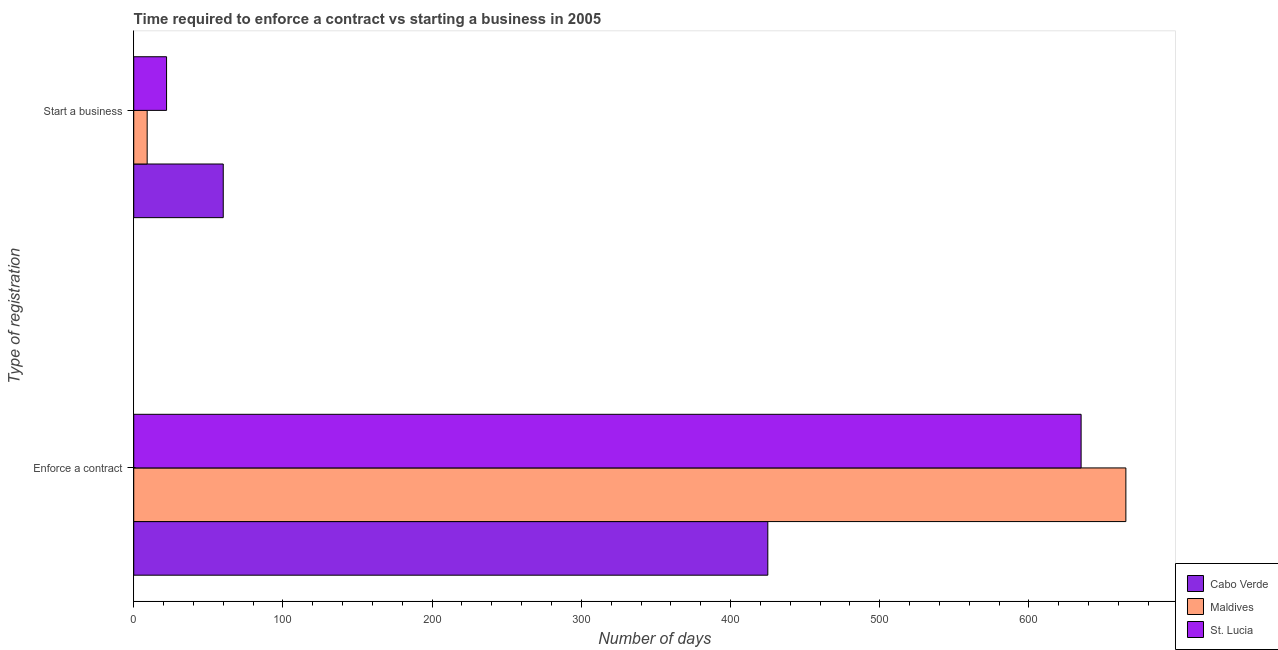Are the number of bars per tick equal to the number of legend labels?
Give a very brief answer. Yes. How many bars are there on the 2nd tick from the top?
Your answer should be very brief. 3. How many bars are there on the 2nd tick from the bottom?
Provide a succinct answer. 3. What is the label of the 2nd group of bars from the top?
Offer a very short reply. Enforce a contract. What is the number of days to enforece a contract in Maldives?
Provide a short and direct response. 665. Across all countries, what is the maximum number of days to enforece a contract?
Provide a succinct answer. 665. Across all countries, what is the minimum number of days to start a business?
Offer a terse response. 9. In which country was the number of days to start a business maximum?
Offer a terse response. Cabo Verde. In which country was the number of days to start a business minimum?
Your answer should be very brief. Maldives. What is the total number of days to enforece a contract in the graph?
Offer a very short reply. 1725. What is the difference between the number of days to start a business in Maldives and that in St. Lucia?
Keep it short and to the point. -13. What is the difference between the number of days to start a business in Maldives and the number of days to enforece a contract in Cabo Verde?
Keep it short and to the point. -416. What is the average number of days to enforece a contract per country?
Your answer should be very brief. 575. What is the difference between the number of days to enforece a contract and number of days to start a business in Cabo Verde?
Make the answer very short. 365. What is the ratio of the number of days to start a business in Cabo Verde to that in St. Lucia?
Your response must be concise. 2.73. Is the number of days to start a business in St. Lucia less than that in Cabo Verde?
Make the answer very short. Yes. What does the 2nd bar from the top in Enforce a contract represents?
Provide a succinct answer. Maldives. What does the 2nd bar from the bottom in Enforce a contract represents?
Your response must be concise. Maldives. How many bars are there?
Your answer should be very brief. 6. Are all the bars in the graph horizontal?
Your answer should be very brief. Yes. How many countries are there in the graph?
Offer a terse response. 3. What is the difference between two consecutive major ticks on the X-axis?
Offer a terse response. 100. Does the graph contain grids?
Make the answer very short. No. How many legend labels are there?
Keep it short and to the point. 3. How are the legend labels stacked?
Provide a short and direct response. Vertical. What is the title of the graph?
Offer a terse response. Time required to enforce a contract vs starting a business in 2005. What is the label or title of the X-axis?
Make the answer very short. Number of days. What is the label or title of the Y-axis?
Provide a short and direct response. Type of registration. What is the Number of days in Cabo Verde in Enforce a contract?
Your answer should be very brief. 425. What is the Number of days of Maldives in Enforce a contract?
Give a very brief answer. 665. What is the Number of days of St. Lucia in Enforce a contract?
Ensure brevity in your answer.  635. What is the Number of days of Cabo Verde in Start a business?
Provide a succinct answer. 60. What is the Number of days in Maldives in Start a business?
Give a very brief answer. 9. Across all Type of registration, what is the maximum Number of days of Cabo Verde?
Offer a terse response. 425. Across all Type of registration, what is the maximum Number of days of Maldives?
Keep it short and to the point. 665. Across all Type of registration, what is the maximum Number of days in St. Lucia?
Keep it short and to the point. 635. Across all Type of registration, what is the minimum Number of days of Maldives?
Make the answer very short. 9. What is the total Number of days of Cabo Verde in the graph?
Keep it short and to the point. 485. What is the total Number of days in Maldives in the graph?
Ensure brevity in your answer.  674. What is the total Number of days of St. Lucia in the graph?
Your answer should be very brief. 657. What is the difference between the Number of days of Cabo Verde in Enforce a contract and that in Start a business?
Offer a terse response. 365. What is the difference between the Number of days in Maldives in Enforce a contract and that in Start a business?
Offer a terse response. 656. What is the difference between the Number of days of St. Lucia in Enforce a contract and that in Start a business?
Make the answer very short. 613. What is the difference between the Number of days in Cabo Verde in Enforce a contract and the Number of days in Maldives in Start a business?
Keep it short and to the point. 416. What is the difference between the Number of days in Cabo Verde in Enforce a contract and the Number of days in St. Lucia in Start a business?
Your response must be concise. 403. What is the difference between the Number of days in Maldives in Enforce a contract and the Number of days in St. Lucia in Start a business?
Your answer should be very brief. 643. What is the average Number of days in Cabo Verde per Type of registration?
Ensure brevity in your answer.  242.5. What is the average Number of days in Maldives per Type of registration?
Give a very brief answer. 337. What is the average Number of days in St. Lucia per Type of registration?
Offer a very short reply. 328.5. What is the difference between the Number of days in Cabo Verde and Number of days in Maldives in Enforce a contract?
Keep it short and to the point. -240. What is the difference between the Number of days in Cabo Verde and Number of days in St. Lucia in Enforce a contract?
Provide a short and direct response. -210. What is the difference between the Number of days in Maldives and Number of days in St. Lucia in Start a business?
Give a very brief answer. -13. What is the ratio of the Number of days in Cabo Verde in Enforce a contract to that in Start a business?
Make the answer very short. 7.08. What is the ratio of the Number of days of Maldives in Enforce a contract to that in Start a business?
Offer a terse response. 73.89. What is the ratio of the Number of days of St. Lucia in Enforce a contract to that in Start a business?
Make the answer very short. 28.86. What is the difference between the highest and the second highest Number of days of Cabo Verde?
Keep it short and to the point. 365. What is the difference between the highest and the second highest Number of days of Maldives?
Your answer should be very brief. 656. What is the difference between the highest and the second highest Number of days of St. Lucia?
Your answer should be very brief. 613. What is the difference between the highest and the lowest Number of days in Cabo Verde?
Offer a terse response. 365. What is the difference between the highest and the lowest Number of days in Maldives?
Give a very brief answer. 656. What is the difference between the highest and the lowest Number of days of St. Lucia?
Your response must be concise. 613. 